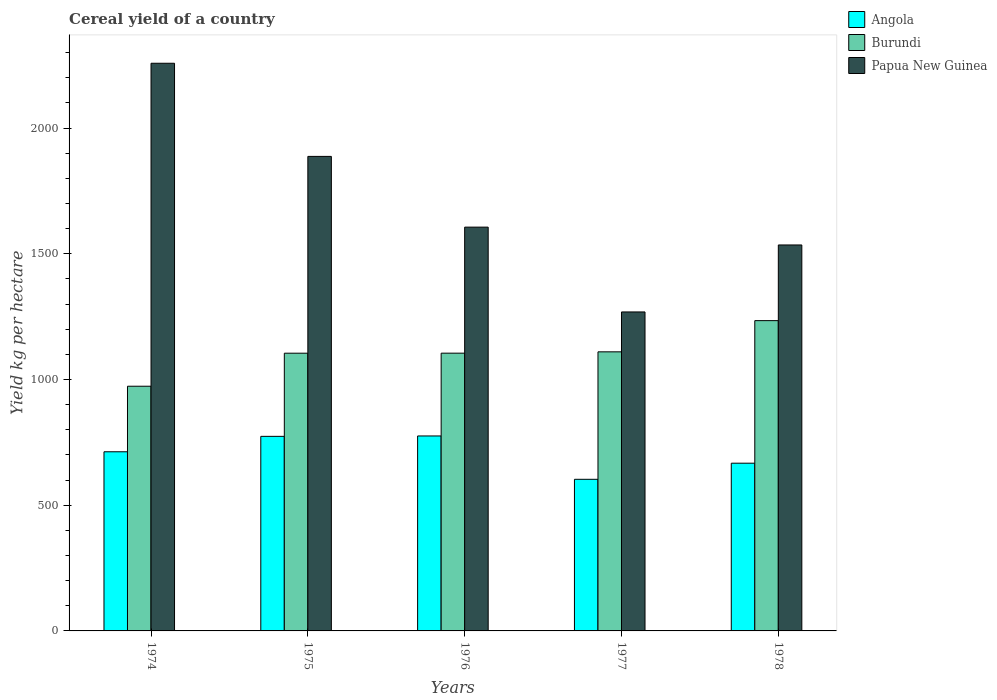How many groups of bars are there?
Provide a short and direct response. 5. How many bars are there on the 4th tick from the right?
Keep it short and to the point. 3. What is the total cereal yield in Angola in 1977?
Your answer should be compact. 603.09. Across all years, what is the maximum total cereal yield in Angola?
Your answer should be compact. 775.48. Across all years, what is the minimum total cereal yield in Angola?
Provide a succinct answer. 603.09. In which year was the total cereal yield in Papua New Guinea maximum?
Provide a succinct answer. 1974. In which year was the total cereal yield in Papua New Guinea minimum?
Make the answer very short. 1977. What is the total total cereal yield in Angola in the graph?
Keep it short and to the point. 3532.2. What is the difference between the total cereal yield in Angola in 1975 and that in 1976?
Give a very brief answer. -1.56. What is the difference between the total cereal yield in Burundi in 1975 and the total cereal yield in Angola in 1974?
Offer a very short reply. 392.11. What is the average total cereal yield in Angola per year?
Keep it short and to the point. 706.44. In the year 1974, what is the difference between the total cereal yield in Burundi and total cereal yield in Papua New Guinea?
Make the answer very short. -1284.66. In how many years, is the total cereal yield in Burundi greater than 1000 kg per hectare?
Your response must be concise. 4. What is the ratio of the total cereal yield in Angola in 1974 to that in 1976?
Make the answer very short. 0.92. What is the difference between the highest and the second highest total cereal yield in Angola?
Give a very brief answer. 1.56. What is the difference between the highest and the lowest total cereal yield in Papua New Guinea?
Offer a very short reply. 989.2. What does the 1st bar from the left in 1974 represents?
Make the answer very short. Angola. What does the 1st bar from the right in 1974 represents?
Offer a terse response. Papua New Guinea. Is it the case that in every year, the sum of the total cereal yield in Papua New Guinea and total cereal yield in Angola is greater than the total cereal yield in Burundi?
Keep it short and to the point. Yes. How many bars are there?
Your response must be concise. 15. How many years are there in the graph?
Make the answer very short. 5. Are the values on the major ticks of Y-axis written in scientific E-notation?
Provide a short and direct response. No. Does the graph contain any zero values?
Offer a terse response. No. Does the graph contain grids?
Your answer should be compact. No. Where does the legend appear in the graph?
Your answer should be very brief. Top right. How many legend labels are there?
Offer a terse response. 3. What is the title of the graph?
Provide a short and direct response. Cereal yield of a country. What is the label or title of the Y-axis?
Ensure brevity in your answer.  Yield kg per hectare. What is the Yield kg per hectare in Angola in 1974?
Make the answer very short. 712.57. What is the Yield kg per hectare in Burundi in 1974?
Make the answer very short. 973.31. What is the Yield kg per hectare in Papua New Guinea in 1974?
Your answer should be very brief. 2257.98. What is the Yield kg per hectare in Angola in 1975?
Your response must be concise. 773.92. What is the Yield kg per hectare of Burundi in 1975?
Keep it short and to the point. 1104.68. What is the Yield kg per hectare in Papua New Guinea in 1975?
Your answer should be very brief. 1887.52. What is the Yield kg per hectare of Angola in 1976?
Provide a short and direct response. 775.48. What is the Yield kg per hectare in Burundi in 1976?
Offer a terse response. 1104.82. What is the Yield kg per hectare of Papua New Guinea in 1976?
Offer a terse response. 1606.15. What is the Yield kg per hectare in Angola in 1977?
Offer a very short reply. 603.09. What is the Yield kg per hectare of Burundi in 1977?
Offer a very short reply. 1110.11. What is the Yield kg per hectare of Papua New Guinea in 1977?
Keep it short and to the point. 1268.77. What is the Yield kg per hectare in Angola in 1978?
Your answer should be very brief. 667.13. What is the Yield kg per hectare in Burundi in 1978?
Keep it short and to the point. 1234.22. What is the Yield kg per hectare of Papua New Guinea in 1978?
Keep it short and to the point. 1535.21. Across all years, what is the maximum Yield kg per hectare in Angola?
Offer a very short reply. 775.48. Across all years, what is the maximum Yield kg per hectare of Burundi?
Offer a terse response. 1234.22. Across all years, what is the maximum Yield kg per hectare in Papua New Guinea?
Your answer should be compact. 2257.98. Across all years, what is the minimum Yield kg per hectare of Angola?
Offer a very short reply. 603.09. Across all years, what is the minimum Yield kg per hectare in Burundi?
Ensure brevity in your answer.  973.31. Across all years, what is the minimum Yield kg per hectare of Papua New Guinea?
Your answer should be very brief. 1268.77. What is the total Yield kg per hectare in Angola in the graph?
Give a very brief answer. 3532.2. What is the total Yield kg per hectare of Burundi in the graph?
Provide a short and direct response. 5527.15. What is the total Yield kg per hectare in Papua New Guinea in the graph?
Make the answer very short. 8555.63. What is the difference between the Yield kg per hectare of Angola in 1974 and that in 1975?
Your answer should be very brief. -61.35. What is the difference between the Yield kg per hectare of Burundi in 1974 and that in 1975?
Give a very brief answer. -131.37. What is the difference between the Yield kg per hectare of Papua New Guinea in 1974 and that in 1975?
Offer a very short reply. 370.46. What is the difference between the Yield kg per hectare in Angola in 1974 and that in 1976?
Provide a short and direct response. -62.91. What is the difference between the Yield kg per hectare of Burundi in 1974 and that in 1976?
Your answer should be compact. -131.51. What is the difference between the Yield kg per hectare of Papua New Guinea in 1974 and that in 1976?
Give a very brief answer. 651.83. What is the difference between the Yield kg per hectare in Angola in 1974 and that in 1977?
Keep it short and to the point. 109.48. What is the difference between the Yield kg per hectare in Burundi in 1974 and that in 1977?
Make the answer very short. -136.8. What is the difference between the Yield kg per hectare of Papua New Guinea in 1974 and that in 1977?
Your answer should be very brief. 989.2. What is the difference between the Yield kg per hectare in Angola in 1974 and that in 1978?
Make the answer very short. 45.44. What is the difference between the Yield kg per hectare in Burundi in 1974 and that in 1978?
Your answer should be compact. -260.91. What is the difference between the Yield kg per hectare in Papua New Guinea in 1974 and that in 1978?
Your answer should be very brief. 722.76. What is the difference between the Yield kg per hectare of Angola in 1975 and that in 1976?
Your response must be concise. -1.56. What is the difference between the Yield kg per hectare in Burundi in 1975 and that in 1976?
Ensure brevity in your answer.  -0.14. What is the difference between the Yield kg per hectare in Papua New Guinea in 1975 and that in 1976?
Provide a succinct answer. 281.37. What is the difference between the Yield kg per hectare in Angola in 1975 and that in 1977?
Offer a very short reply. 170.84. What is the difference between the Yield kg per hectare of Burundi in 1975 and that in 1977?
Ensure brevity in your answer.  -5.43. What is the difference between the Yield kg per hectare of Papua New Guinea in 1975 and that in 1977?
Give a very brief answer. 618.75. What is the difference between the Yield kg per hectare in Angola in 1975 and that in 1978?
Your response must be concise. 106.79. What is the difference between the Yield kg per hectare of Burundi in 1975 and that in 1978?
Provide a short and direct response. -129.54. What is the difference between the Yield kg per hectare in Papua New Guinea in 1975 and that in 1978?
Offer a very short reply. 352.31. What is the difference between the Yield kg per hectare of Angola in 1976 and that in 1977?
Give a very brief answer. 172.4. What is the difference between the Yield kg per hectare of Burundi in 1976 and that in 1977?
Your response must be concise. -5.29. What is the difference between the Yield kg per hectare of Papua New Guinea in 1976 and that in 1977?
Provide a short and direct response. 337.38. What is the difference between the Yield kg per hectare of Angola in 1976 and that in 1978?
Provide a succinct answer. 108.35. What is the difference between the Yield kg per hectare in Burundi in 1976 and that in 1978?
Your answer should be very brief. -129.4. What is the difference between the Yield kg per hectare in Papua New Guinea in 1976 and that in 1978?
Offer a very short reply. 70.94. What is the difference between the Yield kg per hectare of Angola in 1977 and that in 1978?
Your response must be concise. -64.05. What is the difference between the Yield kg per hectare of Burundi in 1977 and that in 1978?
Keep it short and to the point. -124.11. What is the difference between the Yield kg per hectare of Papua New Guinea in 1977 and that in 1978?
Keep it short and to the point. -266.44. What is the difference between the Yield kg per hectare of Angola in 1974 and the Yield kg per hectare of Burundi in 1975?
Keep it short and to the point. -392.11. What is the difference between the Yield kg per hectare of Angola in 1974 and the Yield kg per hectare of Papua New Guinea in 1975?
Make the answer very short. -1174.95. What is the difference between the Yield kg per hectare of Burundi in 1974 and the Yield kg per hectare of Papua New Guinea in 1975?
Provide a short and direct response. -914.21. What is the difference between the Yield kg per hectare of Angola in 1974 and the Yield kg per hectare of Burundi in 1976?
Offer a terse response. -392.25. What is the difference between the Yield kg per hectare in Angola in 1974 and the Yield kg per hectare in Papua New Guinea in 1976?
Ensure brevity in your answer.  -893.58. What is the difference between the Yield kg per hectare of Burundi in 1974 and the Yield kg per hectare of Papua New Guinea in 1976?
Your answer should be very brief. -632.83. What is the difference between the Yield kg per hectare of Angola in 1974 and the Yield kg per hectare of Burundi in 1977?
Your answer should be compact. -397.54. What is the difference between the Yield kg per hectare of Angola in 1974 and the Yield kg per hectare of Papua New Guinea in 1977?
Your answer should be very brief. -556.2. What is the difference between the Yield kg per hectare of Burundi in 1974 and the Yield kg per hectare of Papua New Guinea in 1977?
Your response must be concise. -295.46. What is the difference between the Yield kg per hectare of Angola in 1974 and the Yield kg per hectare of Burundi in 1978?
Offer a terse response. -521.65. What is the difference between the Yield kg per hectare in Angola in 1974 and the Yield kg per hectare in Papua New Guinea in 1978?
Offer a very short reply. -822.64. What is the difference between the Yield kg per hectare of Burundi in 1974 and the Yield kg per hectare of Papua New Guinea in 1978?
Make the answer very short. -561.9. What is the difference between the Yield kg per hectare in Angola in 1975 and the Yield kg per hectare in Burundi in 1976?
Provide a short and direct response. -330.9. What is the difference between the Yield kg per hectare of Angola in 1975 and the Yield kg per hectare of Papua New Guinea in 1976?
Provide a succinct answer. -832.22. What is the difference between the Yield kg per hectare in Burundi in 1975 and the Yield kg per hectare in Papua New Guinea in 1976?
Your answer should be compact. -501.47. What is the difference between the Yield kg per hectare in Angola in 1975 and the Yield kg per hectare in Burundi in 1977?
Offer a terse response. -336.19. What is the difference between the Yield kg per hectare of Angola in 1975 and the Yield kg per hectare of Papua New Guinea in 1977?
Make the answer very short. -494.85. What is the difference between the Yield kg per hectare in Burundi in 1975 and the Yield kg per hectare in Papua New Guinea in 1977?
Make the answer very short. -164.09. What is the difference between the Yield kg per hectare of Angola in 1975 and the Yield kg per hectare of Burundi in 1978?
Your response must be concise. -460.3. What is the difference between the Yield kg per hectare in Angola in 1975 and the Yield kg per hectare in Papua New Guinea in 1978?
Ensure brevity in your answer.  -761.29. What is the difference between the Yield kg per hectare of Burundi in 1975 and the Yield kg per hectare of Papua New Guinea in 1978?
Your response must be concise. -430.53. What is the difference between the Yield kg per hectare of Angola in 1976 and the Yield kg per hectare of Burundi in 1977?
Make the answer very short. -334.63. What is the difference between the Yield kg per hectare of Angola in 1976 and the Yield kg per hectare of Papua New Guinea in 1977?
Your response must be concise. -493.29. What is the difference between the Yield kg per hectare in Burundi in 1976 and the Yield kg per hectare in Papua New Guinea in 1977?
Offer a terse response. -163.95. What is the difference between the Yield kg per hectare in Angola in 1976 and the Yield kg per hectare in Burundi in 1978?
Your answer should be compact. -458.74. What is the difference between the Yield kg per hectare of Angola in 1976 and the Yield kg per hectare of Papua New Guinea in 1978?
Keep it short and to the point. -759.73. What is the difference between the Yield kg per hectare in Burundi in 1976 and the Yield kg per hectare in Papua New Guinea in 1978?
Your answer should be very brief. -430.39. What is the difference between the Yield kg per hectare in Angola in 1977 and the Yield kg per hectare in Burundi in 1978?
Offer a terse response. -631.13. What is the difference between the Yield kg per hectare in Angola in 1977 and the Yield kg per hectare in Papua New Guinea in 1978?
Provide a short and direct response. -932.12. What is the difference between the Yield kg per hectare in Burundi in 1977 and the Yield kg per hectare in Papua New Guinea in 1978?
Provide a succinct answer. -425.1. What is the average Yield kg per hectare of Angola per year?
Your answer should be very brief. 706.44. What is the average Yield kg per hectare in Burundi per year?
Give a very brief answer. 1105.43. What is the average Yield kg per hectare of Papua New Guinea per year?
Your response must be concise. 1711.13. In the year 1974, what is the difference between the Yield kg per hectare in Angola and Yield kg per hectare in Burundi?
Your answer should be very brief. -260.74. In the year 1974, what is the difference between the Yield kg per hectare of Angola and Yield kg per hectare of Papua New Guinea?
Keep it short and to the point. -1545.4. In the year 1974, what is the difference between the Yield kg per hectare of Burundi and Yield kg per hectare of Papua New Guinea?
Offer a terse response. -1284.66. In the year 1975, what is the difference between the Yield kg per hectare in Angola and Yield kg per hectare in Burundi?
Offer a terse response. -330.75. In the year 1975, what is the difference between the Yield kg per hectare of Angola and Yield kg per hectare of Papua New Guinea?
Ensure brevity in your answer.  -1113.59. In the year 1975, what is the difference between the Yield kg per hectare of Burundi and Yield kg per hectare of Papua New Guinea?
Keep it short and to the point. -782.84. In the year 1976, what is the difference between the Yield kg per hectare in Angola and Yield kg per hectare in Burundi?
Offer a very short reply. -329.34. In the year 1976, what is the difference between the Yield kg per hectare in Angola and Yield kg per hectare in Papua New Guinea?
Give a very brief answer. -830.67. In the year 1976, what is the difference between the Yield kg per hectare in Burundi and Yield kg per hectare in Papua New Guinea?
Offer a terse response. -501.32. In the year 1977, what is the difference between the Yield kg per hectare of Angola and Yield kg per hectare of Burundi?
Make the answer very short. -507.03. In the year 1977, what is the difference between the Yield kg per hectare of Angola and Yield kg per hectare of Papua New Guinea?
Keep it short and to the point. -665.69. In the year 1977, what is the difference between the Yield kg per hectare of Burundi and Yield kg per hectare of Papua New Guinea?
Your response must be concise. -158.66. In the year 1978, what is the difference between the Yield kg per hectare in Angola and Yield kg per hectare in Burundi?
Your response must be concise. -567.09. In the year 1978, what is the difference between the Yield kg per hectare in Angola and Yield kg per hectare in Papua New Guinea?
Your answer should be very brief. -868.08. In the year 1978, what is the difference between the Yield kg per hectare of Burundi and Yield kg per hectare of Papua New Guinea?
Your answer should be compact. -300.99. What is the ratio of the Yield kg per hectare of Angola in 1974 to that in 1975?
Give a very brief answer. 0.92. What is the ratio of the Yield kg per hectare in Burundi in 1974 to that in 1975?
Your answer should be compact. 0.88. What is the ratio of the Yield kg per hectare of Papua New Guinea in 1974 to that in 1975?
Give a very brief answer. 1.2. What is the ratio of the Yield kg per hectare in Angola in 1974 to that in 1976?
Offer a terse response. 0.92. What is the ratio of the Yield kg per hectare of Burundi in 1974 to that in 1976?
Offer a terse response. 0.88. What is the ratio of the Yield kg per hectare in Papua New Guinea in 1974 to that in 1976?
Offer a very short reply. 1.41. What is the ratio of the Yield kg per hectare in Angola in 1974 to that in 1977?
Offer a terse response. 1.18. What is the ratio of the Yield kg per hectare in Burundi in 1974 to that in 1977?
Ensure brevity in your answer.  0.88. What is the ratio of the Yield kg per hectare in Papua New Guinea in 1974 to that in 1977?
Your answer should be very brief. 1.78. What is the ratio of the Yield kg per hectare of Angola in 1974 to that in 1978?
Your answer should be compact. 1.07. What is the ratio of the Yield kg per hectare of Burundi in 1974 to that in 1978?
Ensure brevity in your answer.  0.79. What is the ratio of the Yield kg per hectare of Papua New Guinea in 1974 to that in 1978?
Keep it short and to the point. 1.47. What is the ratio of the Yield kg per hectare of Angola in 1975 to that in 1976?
Your answer should be compact. 1. What is the ratio of the Yield kg per hectare in Papua New Guinea in 1975 to that in 1976?
Keep it short and to the point. 1.18. What is the ratio of the Yield kg per hectare of Angola in 1975 to that in 1977?
Give a very brief answer. 1.28. What is the ratio of the Yield kg per hectare of Burundi in 1975 to that in 1977?
Offer a terse response. 1. What is the ratio of the Yield kg per hectare of Papua New Guinea in 1975 to that in 1977?
Make the answer very short. 1.49. What is the ratio of the Yield kg per hectare of Angola in 1975 to that in 1978?
Provide a succinct answer. 1.16. What is the ratio of the Yield kg per hectare in Burundi in 1975 to that in 1978?
Provide a succinct answer. 0.9. What is the ratio of the Yield kg per hectare in Papua New Guinea in 1975 to that in 1978?
Ensure brevity in your answer.  1.23. What is the ratio of the Yield kg per hectare in Angola in 1976 to that in 1977?
Offer a very short reply. 1.29. What is the ratio of the Yield kg per hectare in Papua New Guinea in 1976 to that in 1977?
Your response must be concise. 1.27. What is the ratio of the Yield kg per hectare of Angola in 1976 to that in 1978?
Ensure brevity in your answer.  1.16. What is the ratio of the Yield kg per hectare in Burundi in 1976 to that in 1978?
Your response must be concise. 0.9. What is the ratio of the Yield kg per hectare of Papua New Guinea in 1976 to that in 1978?
Your answer should be very brief. 1.05. What is the ratio of the Yield kg per hectare in Angola in 1977 to that in 1978?
Offer a very short reply. 0.9. What is the ratio of the Yield kg per hectare in Burundi in 1977 to that in 1978?
Offer a very short reply. 0.9. What is the ratio of the Yield kg per hectare of Papua New Guinea in 1977 to that in 1978?
Offer a terse response. 0.83. What is the difference between the highest and the second highest Yield kg per hectare in Angola?
Your answer should be compact. 1.56. What is the difference between the highest and the second highest Yield kg per hectare of Burundi?
Your response must be concise. 124.11. What is the difference between the highest and the second highest Yield kg per hectare of Papua New Guinea?
Offer a terse response. 370.46. What is the difference between the highest and the lowest Yield kg per hectare in Angola?
Your response must be concise. 172.4. What is the difference between the highest and the lowest Yield kg per hectare of Burundi?
Offer a very short reply. 260.91. What is the difference between the highest and the lowest Yield kg per hectare in Papua New Guinea?
Ensure brevity in your answer.  989.2. 